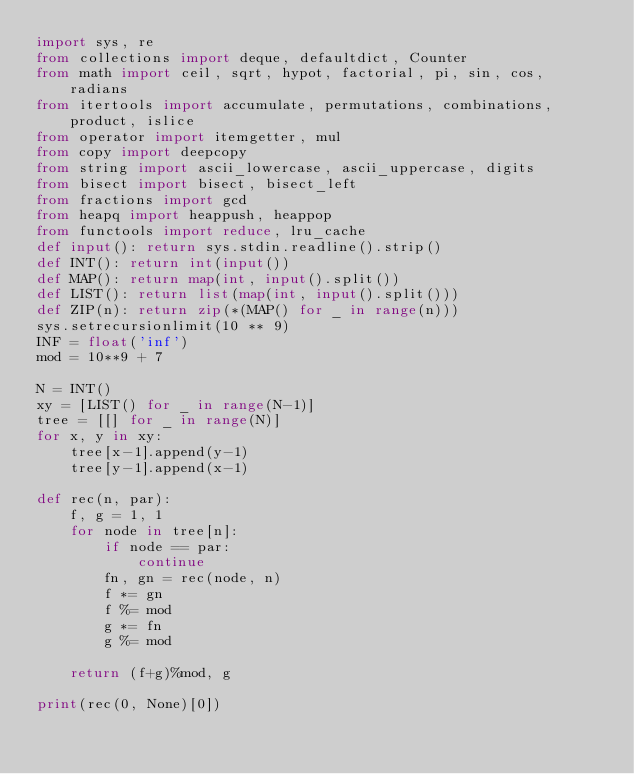Convert code to text. <code><loc_0><loc_0><loc_500><loc_500><_Python_>import sys, re
from collections import deque, defaultdict, Counter
from math import ceil, sqrt, hypot, factorial, pi, sin, cos, radians
from itertools import accumulate, permutations, combinations, product, islice
from operator import itemgetter, mul
from copy import deepcopy
from string import ascii_lowercase, ascii_uppercase, digits
from bisect import bisect, bisect_left
from fractions import gcd
from heapq import heappush, heappop
from functools import reduce, lru_cache
def input(): return sys.stdin.readline().strip()
def INT(): return int(input())
def MAP(): return map(int, input().split())
def LIST(): return list(map(int, input().split()))
def ZIP(n): return zip(*(MAP() for _ in range(n)))
sys.setrecursionlimit(10 ** 9)
INF = float('inf')
mod = 10**9 + 7

N = INT()
xy = [LIST() for _ in range(N-1)]
tree = [[] for _ in range(N)]
for x, y in xy:
    tree[x-1].append(y-1)
    tree[y-1].append(x-1)

def rec(n, par):
    f, g = 1, 1
    for node in tree[n]:
        if node == par:
            continue
        fn, gn = rec(node, n)
        f *= gn
        f %= mod
        g *= fn
        g %= mod
 
    return (f+g)%mod, g
 
print(rec(0, None)[0])
</code> 